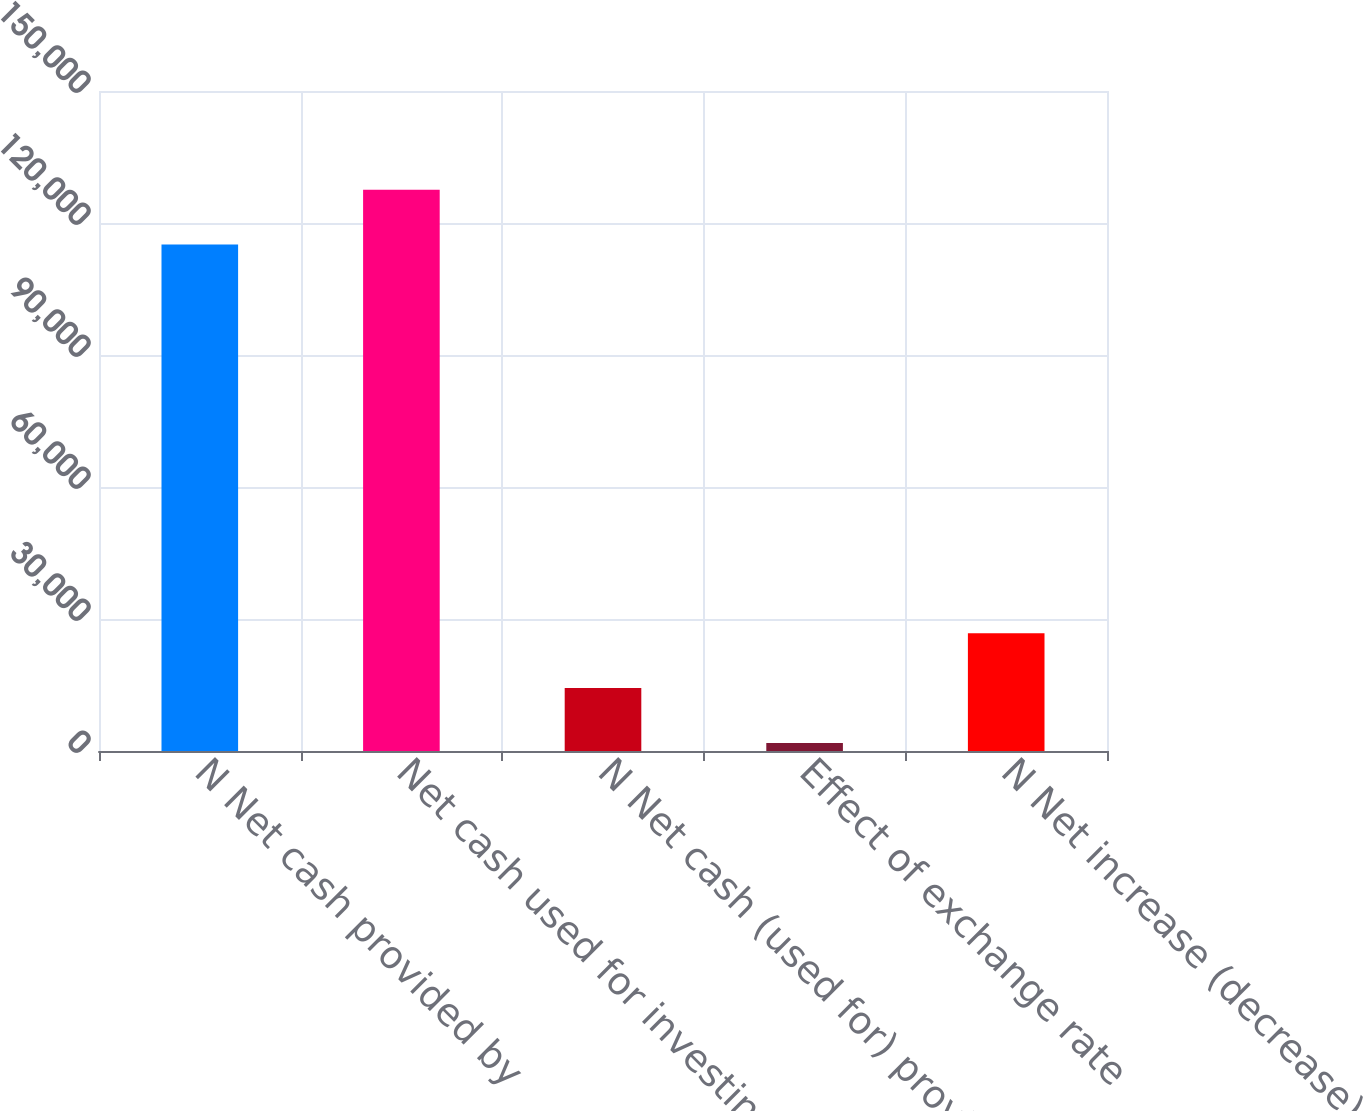Convert chart. <chart><loc_0><loc_0><loc_500><loc_500><bar_chart><fcel>N Net cash provided by<fcel>Net cash used for investing<fcel>N Net cash (used for) provided<fcel>Effect of exchange rate<fcel>N Net increase (decrease) in<nl><fcel>115116<fcel>127565<fcel>14290.2<fcel>1841<fcel>26739.4<nl></chart> 